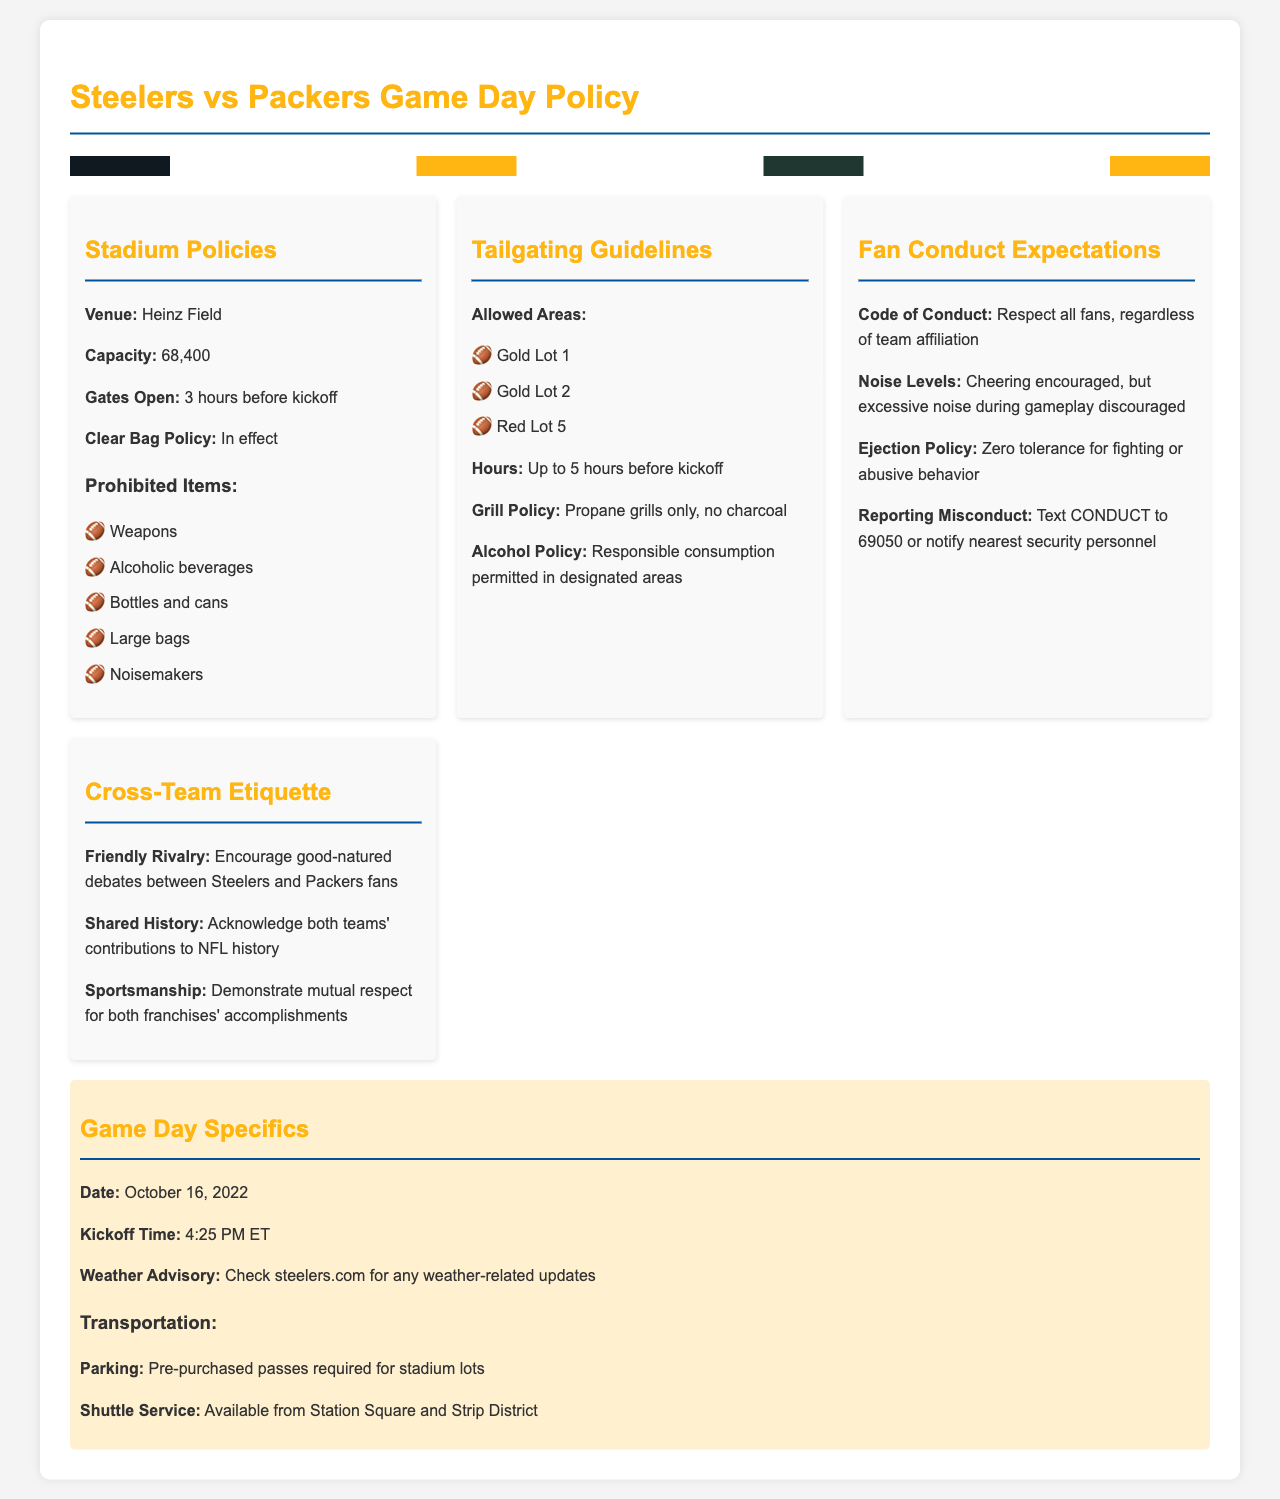What is the venue for the game? The venue is specified in the document as Heinz Field.
Answer: Heinz Field What time do the gates open? The document mentions that the gates open 3 hours before kickoff.
Answer: 3 hours before kickoff What is the maximum capacity of the stadium? The published capacity of Heinz Field is noted to be 68,400 in the document.
Answer: 68,400 How many tailgating lots are permitted? The document lists three specific lots where tailgating is allowed.
Answer: 3 What is the grill policy for tailgating? The document specifies that only propane grills are permitted for tailgating.
Answer: Propane grills only What should fans do if they witness misconduct? The document provides a method to report misconduct, including texting a specific keyword to a number.
Answer: Text CONDUCT to 69050 What is expected of fans in terms of noise levels? The document emphasizes that cheering is encouraged, but excessive noise during gameplay is discouraged.
Answer: Excessive noise during gameplay discouraged What type of rivalry is encouraged between fans? The document promotes good-natured debates between the Steelers and Packers fans.
Answer: Good-natured debates What is the parking policy for the game? The document clearly states that pre-purchased passes are required for parking in stadium lots.
Answer: Pre-purchased passes required 